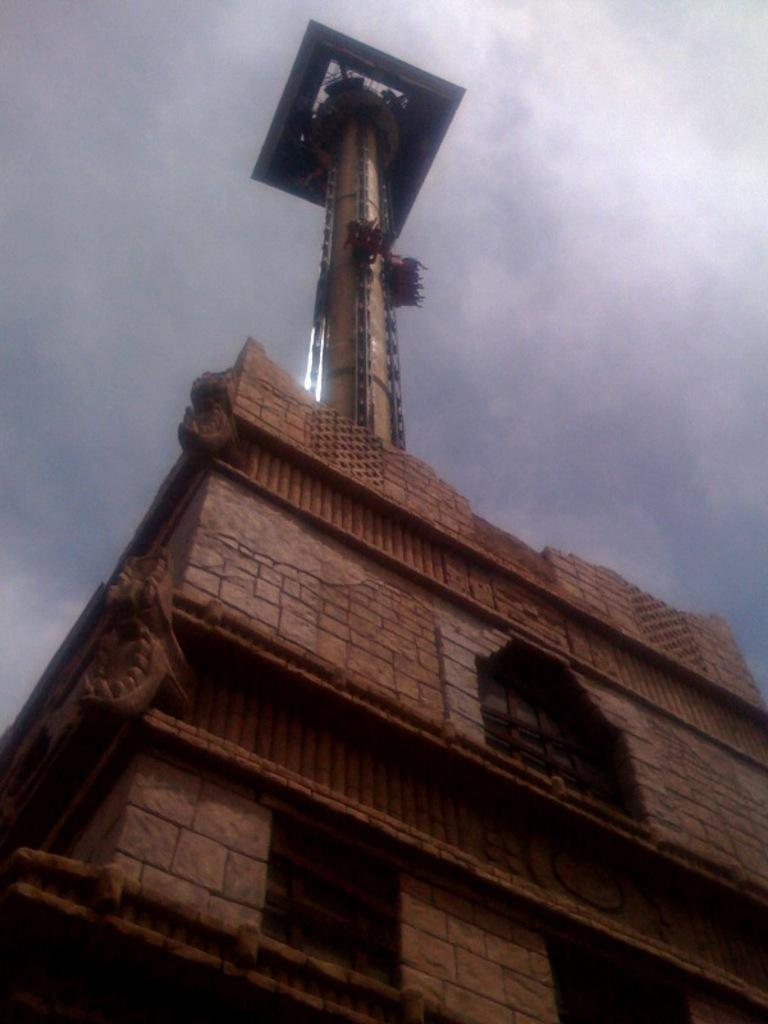What is the main structure in the image? There is a building in the image. What feature can be seen on the building? The building has windows. What is visible in the background of the image? The sky is visible in the image. What can be observed in the sky? Clouds are present in the sky. Where is the iron located in the image? There is no iron present in the image. What type of street can be seen in the image? There is no street visible in the image; it only a building and the sky are present. 